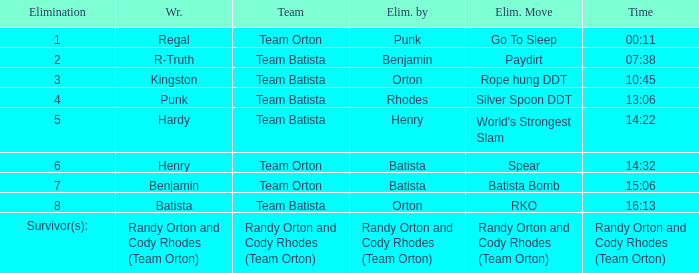When batista eliminated wrestler henry, what elimination move was employed? Spear. 